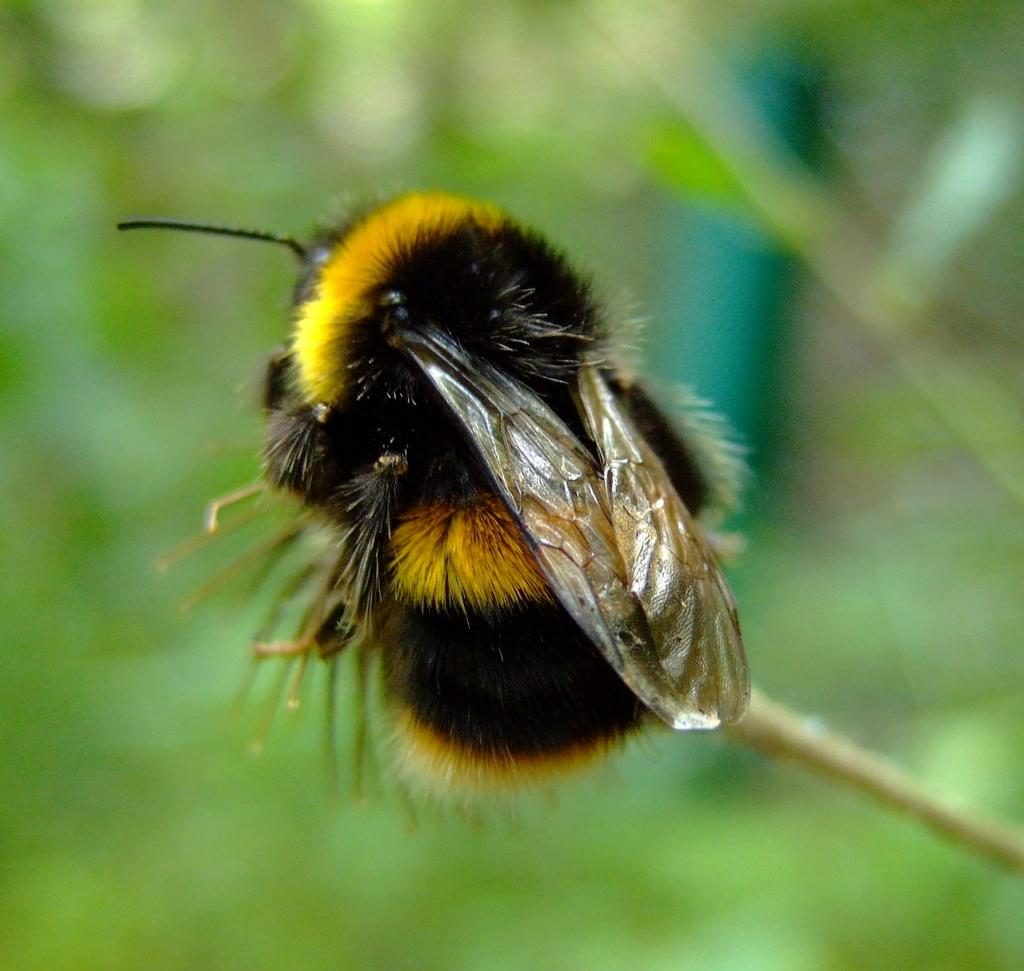What is the person in the image doing with the guitar? The person in the image is playing a guitar. What type of animal is not present in the image? There is no kitten present in the image. What role might the person in the image have in relation to the group of people playing soccer? The person in the image is not shown participating in the soccer game, so it is not possible to determine their role. What type of coach is present in the image? There is no coach present in the image. --- Facts: 1. There is a person in the image. 2. The person is holding a book. 3. The book is titled "The Art of War" by Sun Tzu. 4. The person is sitting on a chair. 5. The chair is made of wood. 6. The background of the image is a library. Absurd Topics: unicorn, magic wand, flying carpet Conversation: What is the person in the image holding? The person in the image is holding a book titled "The Art of War" by Sun Tzu. What type of chair is the person sitting on? The person is sitting on a chair made of wood. What is the background of the image? The background of the image is a library. Reasoning: Let's think step by step in order to produce the conversation. We start by identifying the main subject in the image, which is the person holding a book. Then, we describe specific details about the person and the book they are holding. Next, we mention the type of chair the person is sitting on. Finally, we describe the background of the image. Absurd Question/Answer: Can you see a unicorn in the image? No, there is no unicorn present in the image. --- Facts: 1. There is a group of people in the image. 2. The group of people is playing a game of chess. 3. The chess board is made of wood. 4. The background of the image is a park. Absurd Topics: giant squid, underwater city, sea monsters Conversation: What game are the group of people in the image playing? The group of people in the image is playing a game of chess. What material is the chess board made of? The chess board is made of wood. What is the background of the image? The background of the image is a park. Reasoning: Let's think step by step in order to produce the conversation. We start by identifying the main subject in the image, which is the group of people playing a game of chess. Then, we describe specific details about the chess board. Finally, we describe the background of the image. Absurd Question/Answer: Can you see a giant squid in the image? No, there is no giant 